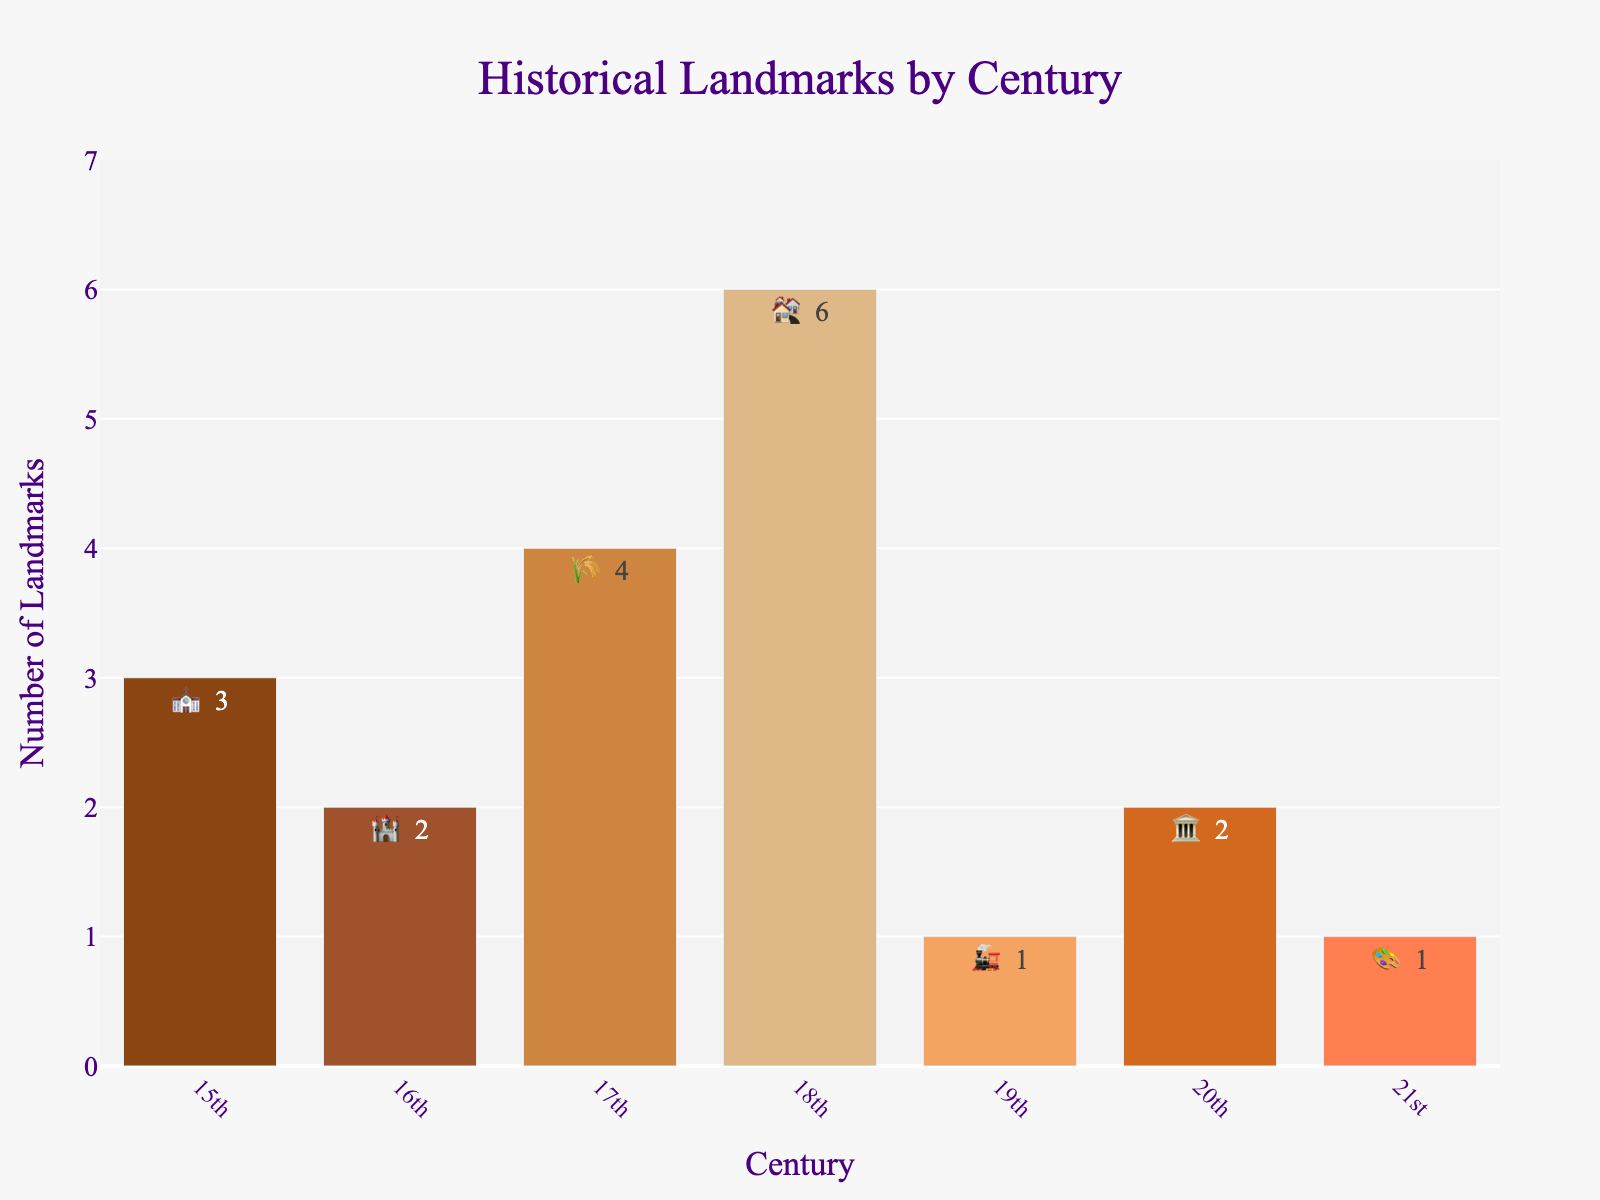What's the title of the chart? The title of the chart is located at the top of the figure and provides a summary of the data being presented.
Answer: Historical Landmarks by Century How many landmarks are represented from the 20th century? To find the number of landmarks from the 20th century, look at the bar labeled "20th" and read the number on the bar or within the text.
Answer: 2 Which century has the highest number of landmarks? Compare the heights of the bars for each century. The tallest bar indicates the century with the most landmarks.
Answer: 18th What is the sum of landmarks from the 15th and 17th centuries? Add the counts from the bars for the 15th and 17th centuries: 3 (15th) + 4 (17th).
Answer: 7 How many landmarks are there in total across all centuries? Add the counts from all centuries: 3 (15th) + 2 (16th) + 4 (17th) + 6 (18th) + 1 (19th) + 2 (20th) + 1 (21st).
Answer: 19 Which landmark has the lowest count? Identify the bar with the shortest height or lowest number, and note the corresponding landmark.
Answer: Victoria Railway Station or Modern Art Gallery (both 1) Are there more landmarks from the 16th or the 21st century? Compare the counts for the bars representing the 16th and 21st centuries.
Answer: 16th century What is the difference in the number of landmarks between the Georgian Townhouses and the War Memorial? Subtract the number of landmarks for the War Memorial from the Georgian Townhouses: 6 (Georgian) - 2 (War Memorial).
Answer: 4 How many centuries have exactly one landmark? Count the number of bars that have a height corresponding to 1 landmark.
Answer: 2 Which landmark is represented with the 🎨 emoji? Look for the text or hovertext associated with the 🎨 emoji in the bar chart to identify the corresponding landmark.
Answer: Modern Art Gallery 